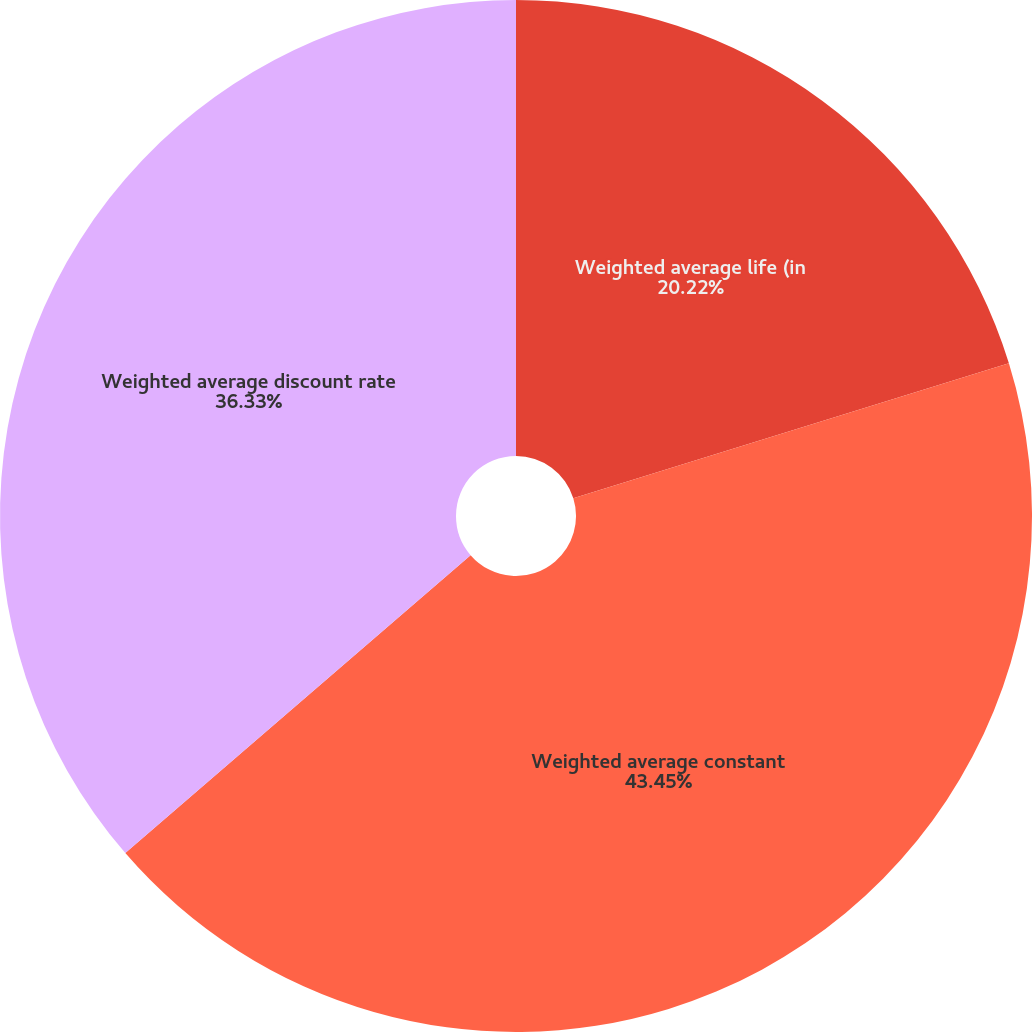Convert chart to OTSL. <chart><loc_0><loc_0><loc_500><loc_500><pie_chart><fcel>Weighted average life (in<fcel>Weighted average constant<fcel>Weighted average discount rate<nl><fcel>20.22%<fcel>43.45%<fcel>36.33%<nl></chart> 